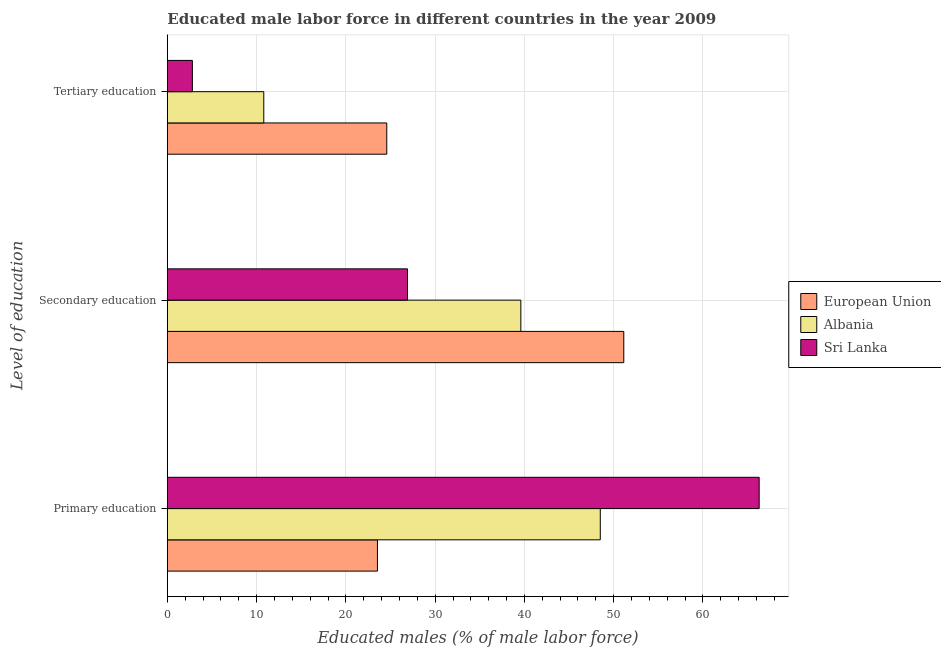How many groups of bars are there?
Give a very brief answer. 3. Are the number of bars on each tick of the Y-axis equal?
Keep it short and to the point. Yes. How many bars are there on the 1st tick from the top?
Offer a terse response. 3. How many bars are there on the 2nd tick from the bottom?
Offer a terse response. 3. What is the label of the 2nd group of bars from the top?
Give a very brief answer. Secondary education. What is the percentage of male labor force who received secondary education in Sri Lanka?
Your answer should be very brief. 26.9. Across all countries, what is the maximum percentage of male labor force who received tertiary education?
Offer a very short reply. 24.58. Across all countries, what is the minimum percentage of male labor force who received secondary education?
Give a very brief answer. 26.9. In which country was the percentage of male labor force who received primary education maximum?
Provide a short and direct response. Sri Lanka. In which country was the percentage of male labor force who received primary education minimum?
Make the answer very short. European Union. What is the total percentage of male labor force who received primary education in the graph?
Give a very brief answer. 138.33. What is the difference between the percentage of male labor force who received secondary education in European Union and that in Sri Lanka?
Ensure brevity in your answer.  24.23. What is the difference between the percentage of male labor force who received primary education in Albania and the percentage of male labor force who received secondary education in European Union?
Offer a very short reply. -2.63. What is the average percentage of male labor force who received tertiary education per country?
Your response must be concise. 12.73. What is the difference between the percentage of male labor force who received primary education and percentage of male labor force who received secondary education in Sri Lanka?
Offer a terse response. 39.4. In how many countries, is the percentage of male labor force who received primary education greater than 8 %?
Make the answer very short. 3. What is the ratio of the percentage of male labor force who received primary education in Albania to that in Sri Lanka?
Offer a very short reply. 0.73. What is the difference between the highest and the second highest percentage of male labor force who received secondary education?
Give a very brief answer. 11.53. What is the difference between the highest and the lowest percentage of male labor force who received tertiary education?
Your response must be concise. 21.78. Is the sum of the percentage of male labor force who received secondary education in Albania and European Union greater than the maximum percentage of male labor force who received primary education across all countries?
Ensure brevity in your answer.  Yes. What does the 1st bar from the top in Tertiary education represents?
Make the answer very short. Sri Lanka. Is it the case that in every country, the sum of the percentage of male labor force who received primary education and percentage of male labor force who received secondary education is greater than the percentage of male labor force who received tertiary education?
Your answer should be compact. Yes. Are all the bars in the graph horizontal?
Your answer should be very brief. Yes. What is the difference between two consecutive major ticks on the X-axis?
Your response must be concise. 10. Are the values on the major ticks of X-axis written in scientific E-notation?
Your response must be concise. No. Does the graph contain grids?
Make the answer very short. Yes. Where does the legend appear in the graph?
Make the answer very short. Center right. What is the title of the graph?
Make the answer very short. Educated male labor force in different countries in the year 2009. What is the label or title of the X-axis?
Make the answer very short. Educated males (% of male labor force). What is the label or title of the Y-axis?
Provide a succinct answer. Level of education. What is the Educated males (% of male labor force) in European Union in Primary education?
Make the answer very short. 23.53. What is the Educated males (% of male labor force) in Albania in Primary education?
Your answer should be very brief. 48.5. What is the Educated males (% of male labor force) in Sri Lanka in Primary education?
Give a very brief answer. 66.3. What is the Educated males (% of male labor force) in European Union in Secondary education?
Offer a terse response. 51.13. What is the Educated males (% of male labor force) of Albania in Secondary education?
Give a very brief answer. 39.6. What is the Educated males (% of male labor force) in Sri Lanka in Secondary education?
Your answer should be very brief. 26.9. What is the Educated males (% of male labor force) in European Union in Tertiary education?
Offer a very short reply. 24.58. What is the Educated males (% of male labor force) of Albania in Tertiary education?
Make the answer very short. 10.8. What is the Educated males (% of male labor force) of Sri Lanka in Tertiary education?
Your answer should be compact. 2.8. Across all Level of education, what is the maximum Educated males (% of male labor force) of European Union?
Offer a terse response. 51.13. Across all Level of education, what is the maximum Educated males (% of male labor force) in Albania?
Keep it short and to the point. 48.5. Across all Level of education, what is the maximum Educated males (% of male labor force) of Sri Lanka?
Your answer should be compact. 66.3. Across all Level of education, what is the minimum Educated males (% of male labor force) of European Union?
Provide a succinct answer. 23.53. Across all Level of education, what is the minimum Educated males (% of male labor force) in Albania?
Make the answer very short. 10.8. Across all Level of education, what is the minimum Educated males (% of male labor force) of Sri Lanka?
Keep it short and to the point. 2.8. What is the total Educated males (% of male labor force) in European Union in the graph?
Ensure brevity in your answer.  99.24. What is the total Educated males (% of male labor force) in Albania in the graph?
Give a very brief answer. 98.9. What is the total Educated males (% of male labor force) of Sri Lanka in the graph?
Keep it short and to the point. 96. What is the difference between the Educated males (% of male labor force) in European Union in Primary education and that in Secondary education?
Your answer should be very brief. -27.6. What is the difference between the Educated males (% of male labor force) of Albania in Primary education and that in Secondary education?
Offer a terse response. 8.9. What is the difference between the Educated males (% of male labor force) of Sri Lanka in Primary education and that in Secondary education?
Your response must be concise. 39.4. What is the difference between the Educated males (% of male labor force) of European Union in Primary education and that in Tertiary education?
Offer a very short reply. -1.04. What is the difference between the Educated males (% of male labor force) of Albania in Primary education and that in Tertiary education?
Offer a terse response. 37.7. What is the difference between the Educated males (% of male labor force) in Sri Lanka in Primary education and that in Tertiary education?
Offer a terse response. 63.5. What is the difference between the Educated males (% of male labor force) in European Union in Secondary education and that in Tertiary education?
Give a very brief answer. 26.55. What is the difference between the Educated males (% of male labor force) in Albania in Secondary education and that in Tertiary education?
Provide a succinct answer. 28.8. What is the difference between the Educated males (% of male labor force) of Sri Lanka in Secondary education and that in Tertiary education?
Provide a short and direct response. 24.1. What is the difference between the Educated males (% of male labor force) in European Union in Primary education and the Educated males (% of male labor force) in Albania in Secondary education?
Give a very brief answer. -16.07. What is the difference between the Educated males (% of male labor force) of European Union in Primary education and the Educated males (% of male labor force) of Sri Lanka in Secondary education?
Keep it short and to the point. -3.37. What is the difference between the Educated males (% of male labor force) of Albania in Primary education and the Educated males (% of male labor force) of Sri Lanka in Secondary education?
Make the answer very short. 21.6. What is the difference between the Educated males (% of male labor force) in European Union in Primary education and the Educated males (% of male labor force) in Albania in Tertiary education?
Offer a very short reply. 12.73. What is the difference between the Educated males (% of male labor force) in European Union in Primary education and the Educated males (% of male labor force) in Sri Lanka in Tertiary education?
Give a very brief answer. 20.73. What is the difference between the Educated males (% of male labor force) of Albania in Primary education and the Educated males (% of male labor force) of Sri Lanka in Tertiary education?
Provide a succinct answer. 45.7. What is the difference between the Educated males (% of male labor force) in European Union in Secondary education and the Educated males (% of male labor force) in Albania in Tertiary education?
Offer a terse response. 40.33. What is the difference between the Educated males (% of male labor force) in European Union in Secondary education and the Educated males (% of male labor force) in Sri Lanka in Tertiary education?
Provide a succinct answer. 48.33. What is the difference between the Educated males (% of male labor force) in Albania in Secondary education and the Educated males (% of male labor force) in Sri Lanka in Tertiary education?
Keep it short and to the point. 36.8. What is the average Educated males (% of male labor force) of European Union per Level of education?
Make the answer very short. 33.08. What is the average Educated males (% of male labor force) in Albania per Level of education?
Your response must be concise. 32.97. What is the average Educated males (% of male labor force) in Sri Lanka per Level of education?
Your answer should be compact. 32. What is the difference between the Educated males (% of male labor force) in European Union and Educated males (% of male labor force) in Albania in Primary education?
Offer a very short reply. -24.97. What is the difference between the Educated males (% of male labor force) of European Union and Educated males (% of male labor force) of Sri Lanka in Primary education?
Make the answer very short. -42.77. What is the difference between the Educated males (% of male labor force) of Albania and Educated males (% of male labor force) of Sri Lanka in Primary education?
Your answer should be compact. -17.8. What is the difference between the Educated males (% of male labor force) in European Union and Educated males (% of male labor force) in Albania in Secondary education?
Your answer should be very brief. 11.53. What is the difference between the Educated males (% of male labor force) of European Union and Educated males (% of male labor force) of Sri Lanka in Secondary education?
Offer a terse response. 24.23. What is the difference between the Educated males (% of male labor force) in Albania and Educated males (% of male labor force) in Sri Lanka in Secondary education?
Offer a very short reply. 12.7. What is the difference between the Educated males (% of male labor force) in European Union and Educated males (% of male labor force) in Albania in Tertiary education?
Offer a terse response. 13.78. What is the difference between the Educated males (% of male labor force) of European Union and Educated males (% of male labor force) of Sri Lanka in Tertiary education?
Provide a short and direct response. 21.78. What is the ratio of the Educated males (% of male labor force) of European Union in Primary education to that in Secondary education?
Provide a succinct answer. 0.46. What is the ratio of the Educated males (% of male labor force) of Albania in Primary education to that in Secondary education?
Your answer should be very brief. 1.22. What is the ratio of the Educated males (% of male labor force) in Sri Lanka in Primary education to that in Secondary education?
Give a very brief answer. 2.46. What is the ratio of the Educated males (% of male labor force) in European Union in Primary education to that in Tertiary education?
Ensure brevity in your answer.  0.96. What is the ratio of the Educated males (% of male labor force) of Albania in Primary education to that in Tertiary education?
Provide a succinct answer. 4.49. What is the ratio of the Educated males (% of male labor force) in Sri Lanka in Primary education to that in Tertiary education?
Give a very brief answer. 23.68. What is the ratio of the Educated males (% of male labor force) in European Union in Secondary education to that in Tertiary education?
Give a very brief answer. 2.08. What is the ratio of the Educated males (% of male labor force) in Albania in Secondary education to that in Tertiary education?
Give a very brief answer. 3.67. What is the ratio of the Educated males (% of male labor force) of Sri Lanka in Secondary education to that in Tertiary education?
Offer a very short reply. 9.61. What is the difference between the highest and the second highest Educated males (% of male labor force) of European Union?
Offer a terse response. 26.55. What is the difference between the highest and the second highest Educated males (% of male labor force) of Sri Lanka?
Offer a very short reply. 39.4. What is the difference between the highest and the lowest Educated males (% of male labor force) in European Union?
Offer a terse response. 27.6. What is the difference between the highest and the lowest Educated males (% of male labor force) of Albania?
Keep it short and to the point. 37.7. What is the difference between the highest and the lowest Educated males (% of male labor force) of Sri Lanka?
Provide a short and direct response. 63.5. 